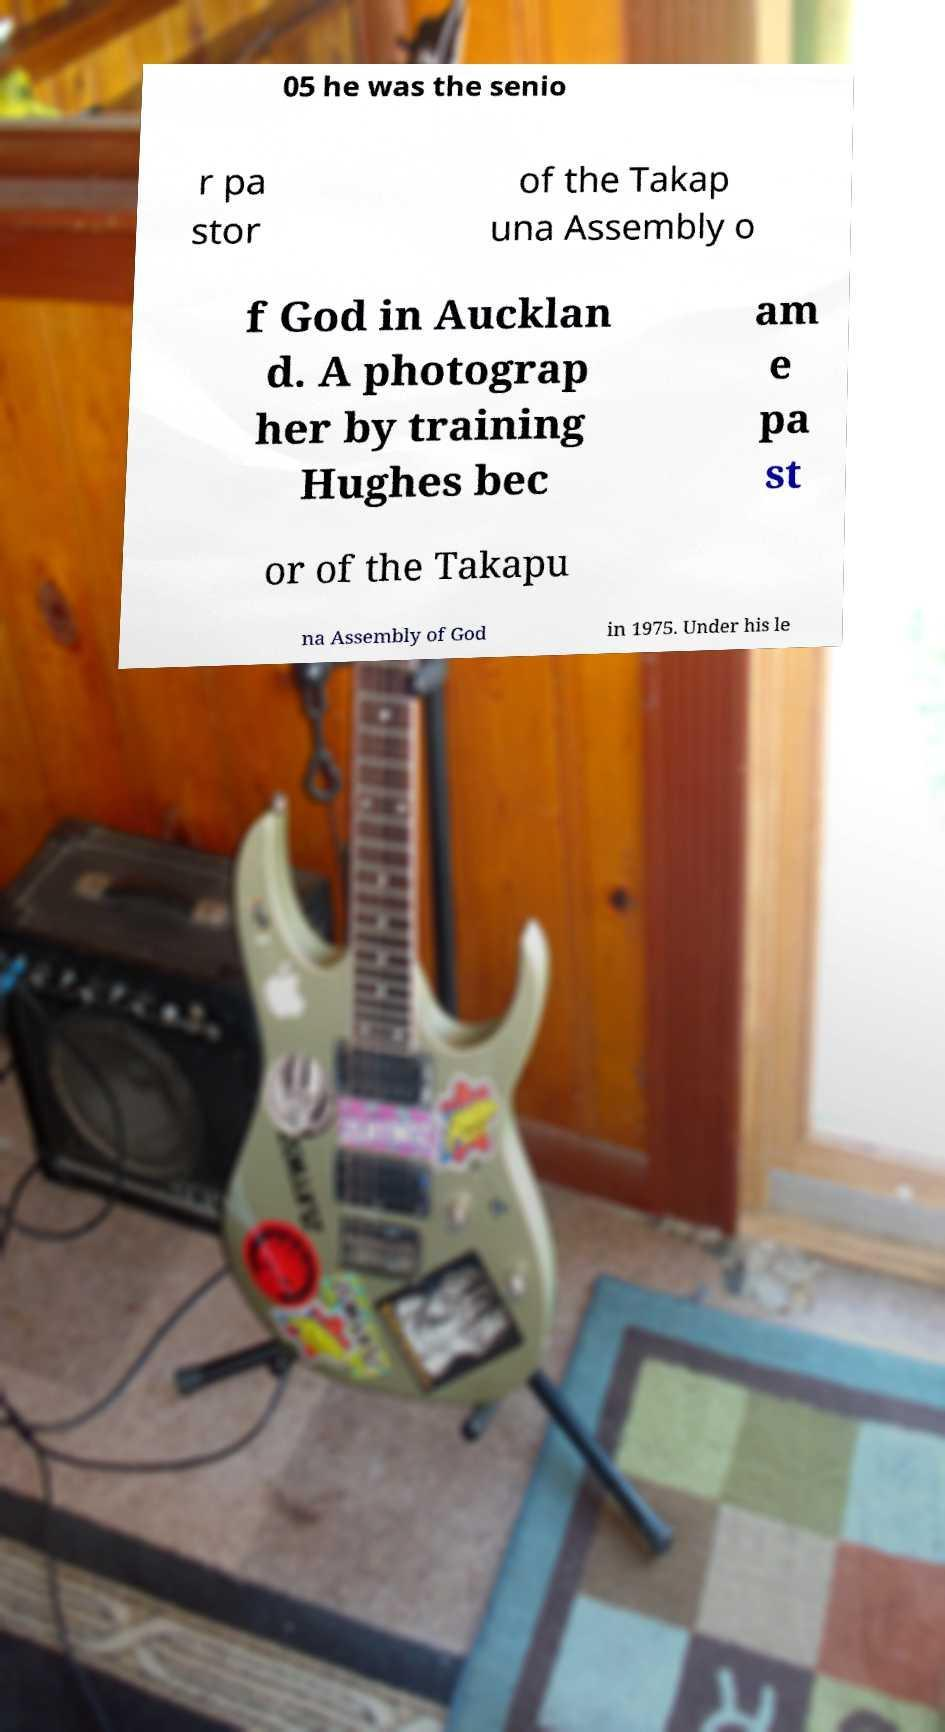Please read and relay the text visible in this image. What does it say? 05 he was the senio r pa stor of the Takap una Assembly o f God in Aucklan d. A photograp her by training Hughes bec am e pa st or of the Takapu na Assembly of God in 1975. Under his le 